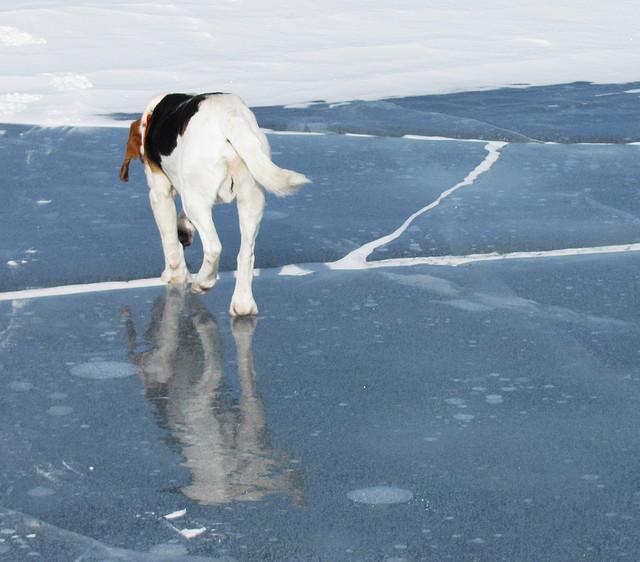Do you see a reflection?
Give a very brief answer. Yes. Does the dog have a leash?
Give a very brief answer. No. What is this animal?
Answer briefly. Dog. Is the dog in a safe place?
Give a very brief answer. No. 